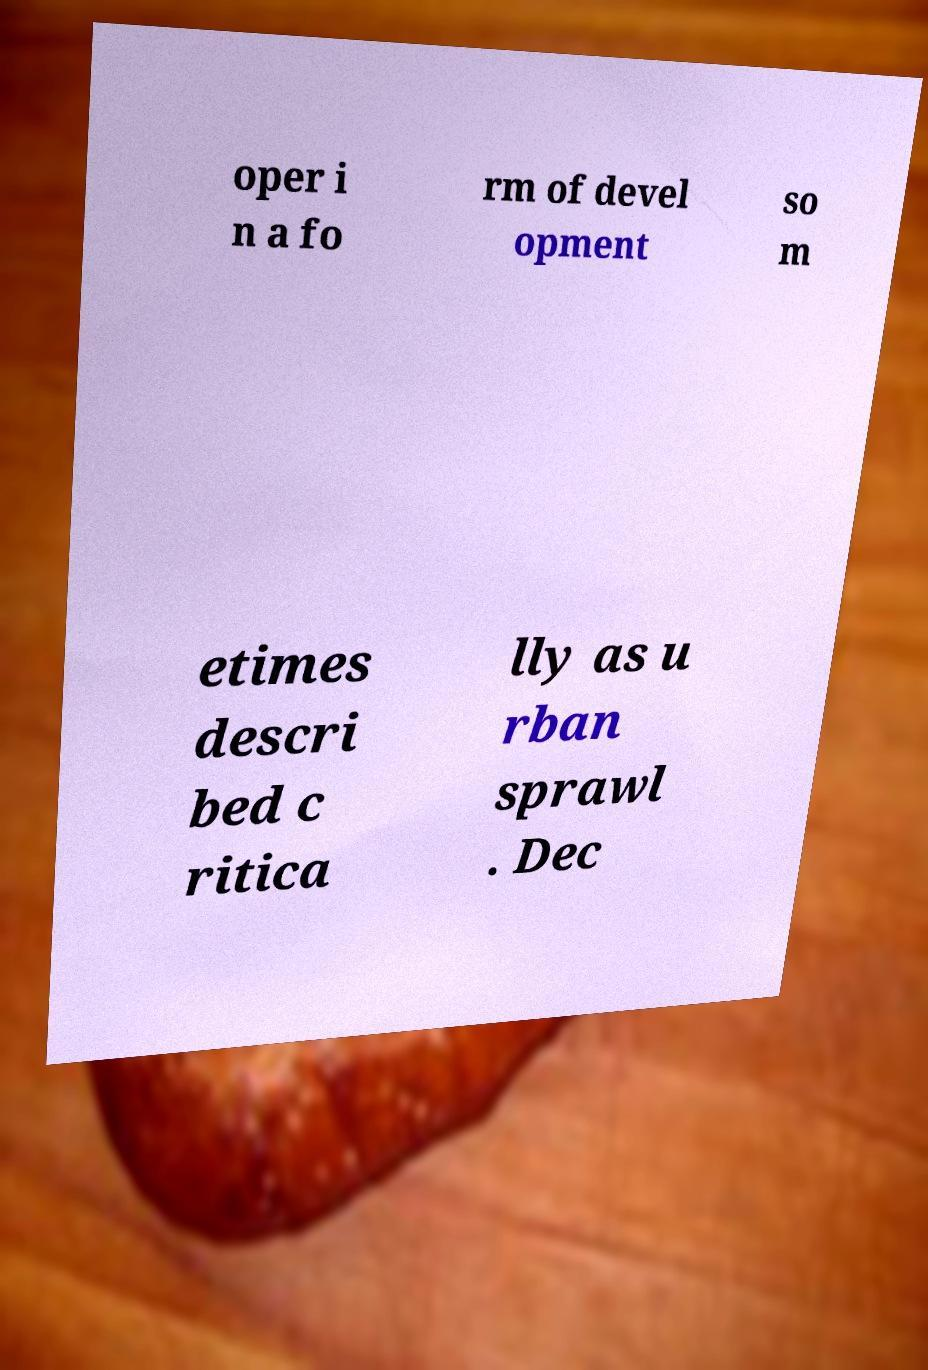Could you assist in decoding the text presented in this image and type it out clearly? oper i n a fo rm of devel opment so m etimes descri bed c ritica lly as u rban sprawl . Dec 